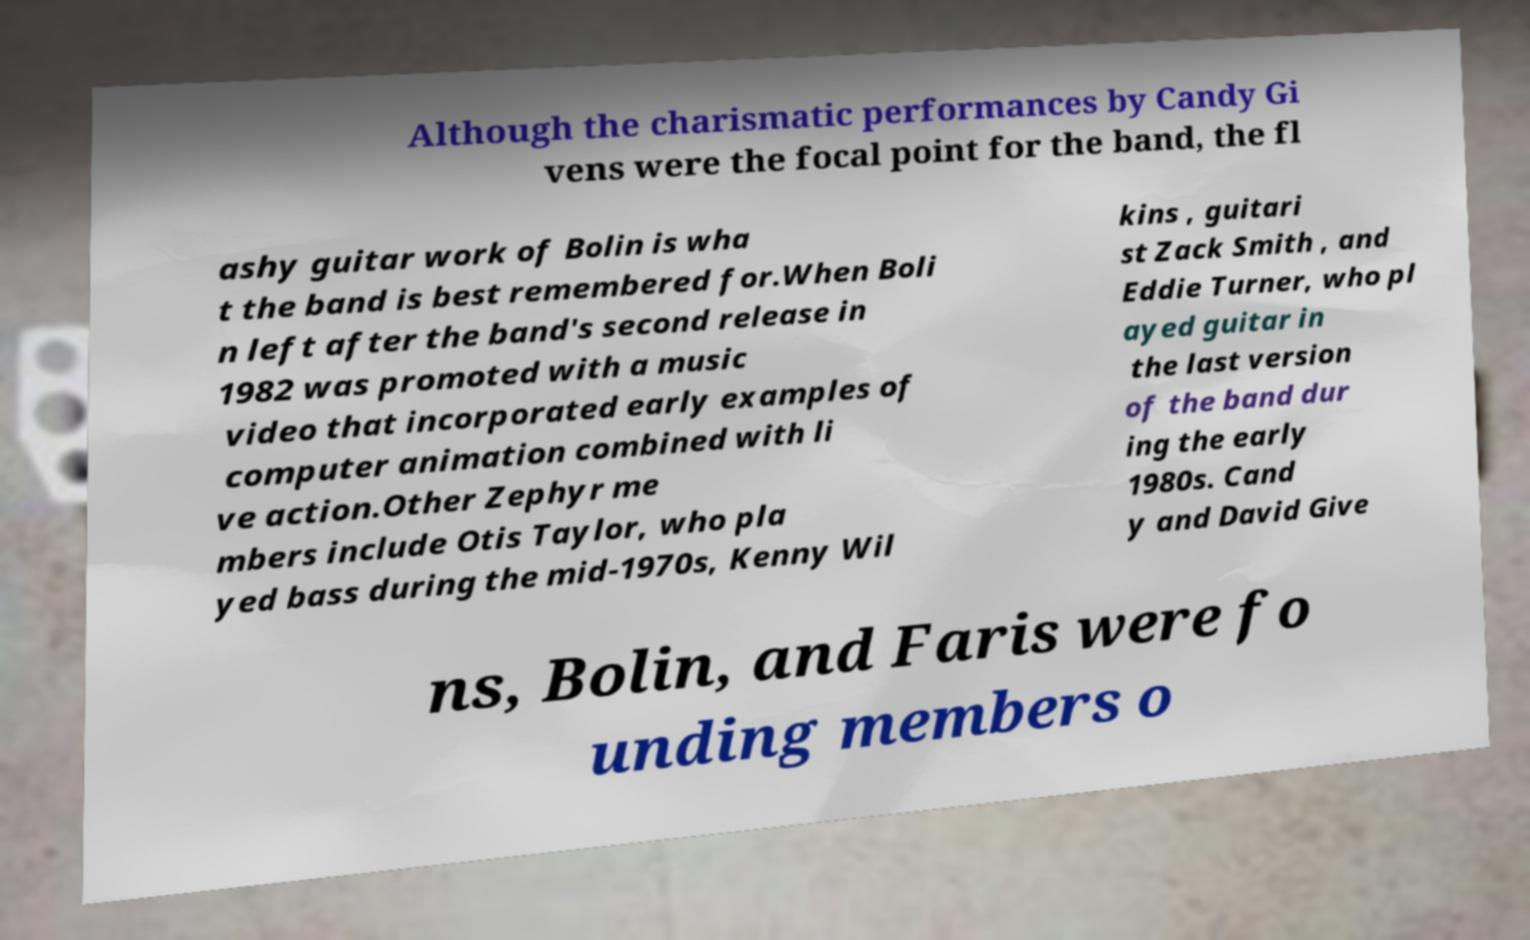Could you assist in decoding the text presented in this image and type it out clearly? Although the charismatic performances by Candy Gi vens were the focal point for the band, the fl ashy guitar work of Bolin is wha t the band is best remembered for.When Boli n left after the band's second release in 1982 was promoted with a music video that incorporated early examples of computer animation combined with li ve action.Other Zephyr me mbers include Otis Taylor, who pla yed bass during the mid-1970s, Kenny Wil kins , guitari st Zack Smith , and Eddie Turner, who pl ayed guitar in the last version of the band dur ing the early 1980s. Cand y and David Give ns, Bolin, and Faris were fo unding members o 